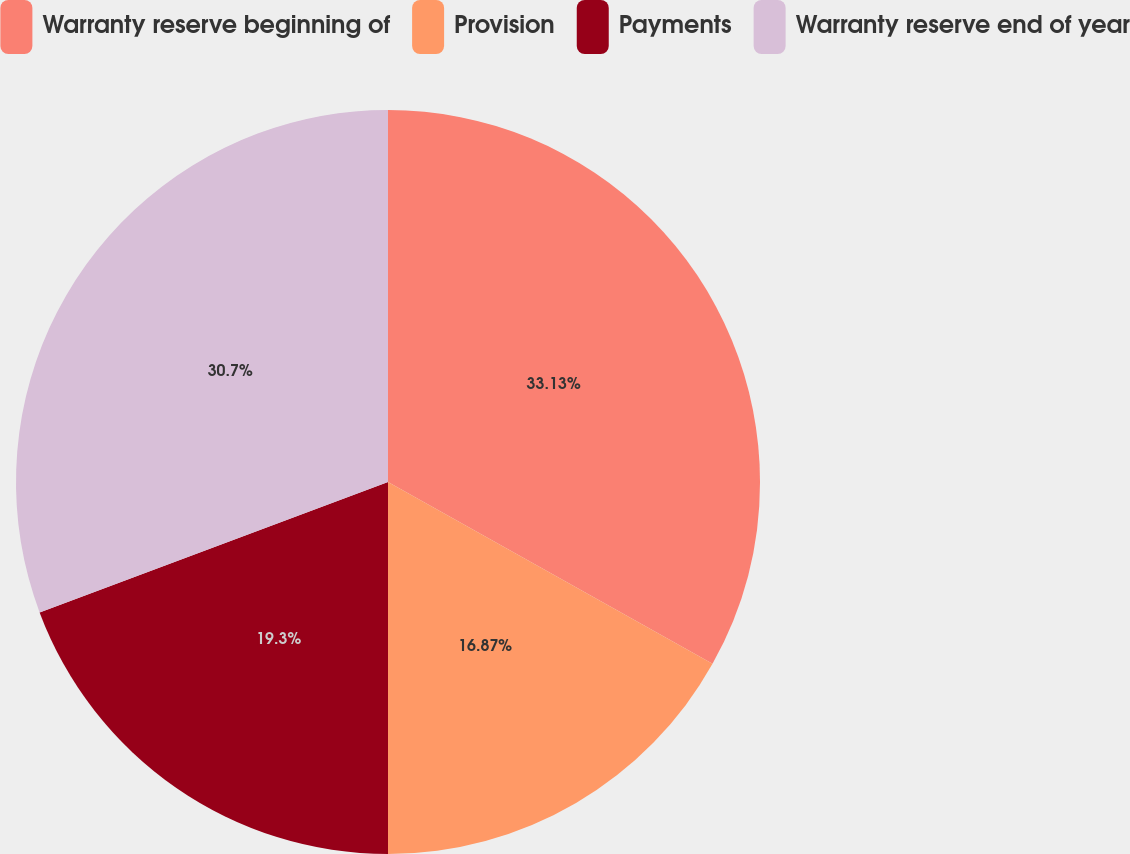<chart> <loc_0><loc_0><loc_500><loc_500><pie_chart><fcel>Warranty reserve beginning of<fcel>Provision<fcel>Payments<fcel>Warranty reserve end of year<nl><fcel>33.13%<fcel>16.87%<fcel>19.3%<fcel>30.7%<nl></chart> 